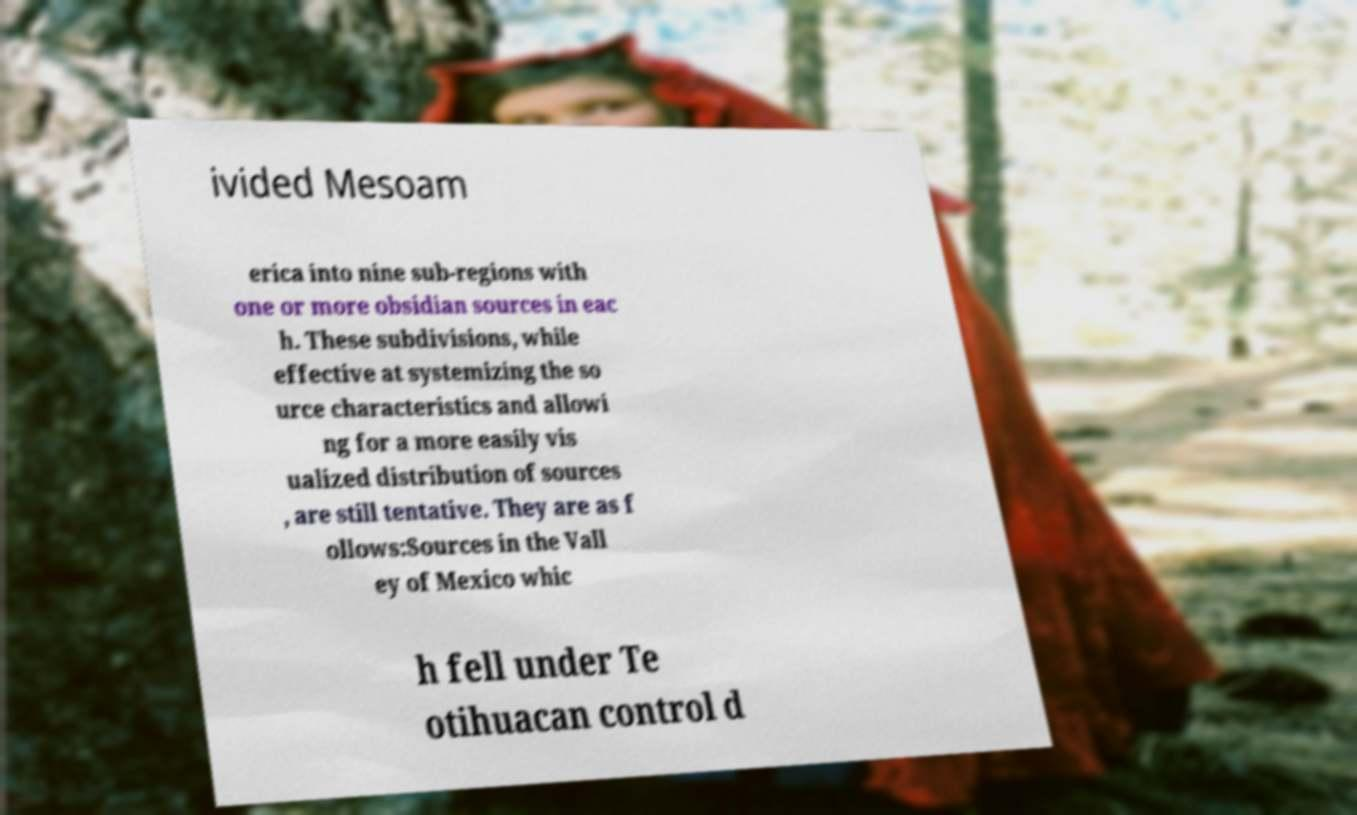What messages or text are displayed in this image? I need them in a readable, typed format. ivided Mesoam erica into nine sub-regions with one or more obsidian sources in eac h. These subdivisions, while effective at systemizing the so urce characteristics and allowi ng for a more easily vis ualized distribution of sources , are still tentative. They are as f ollows:Sources in the Vall ey of Mexico whic h fell under Te otihuacan control d 